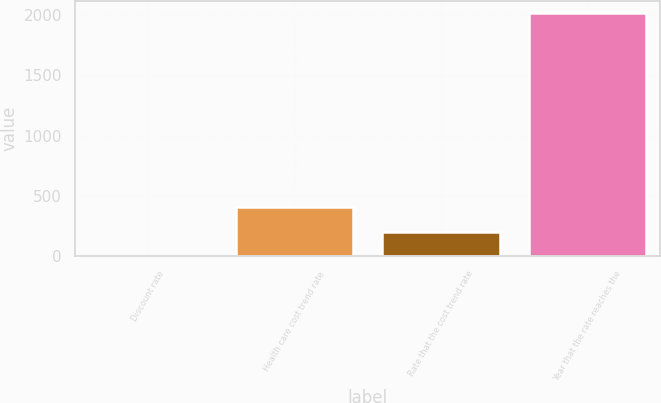Convert chart to OTSL. <chart><loc_0><loc_0><loc_500><loc_500><bar_chart><fcel>Discount rate<fcel>Health care cost trend rate<fcel>Rate that the cost trend rate<fcel>Year that the rate reaches the<nl><fcel>4.5<fcel>407<fcel>205.75<fcel>2017<nl></chart> 